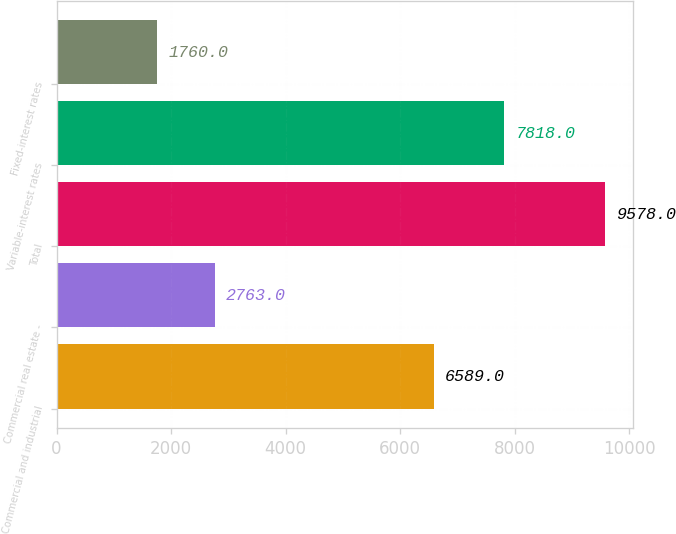Convert chart. <chart><loc_0><loc_0><loc_500><loc_500><bar_chart><fcel>Commercial and industrial<fcel>Commercial real estate -<fcel>Total<fcel>Variable-interest rates<fcel>Fixed-interest rates<nl><fcel>6589<fcel>2763<fcel>9578<fcel>7818<fcel>1760<nl></chart> 